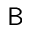<formula> <loc_0><loc_0><loc_500><loc_500>B</formula> 